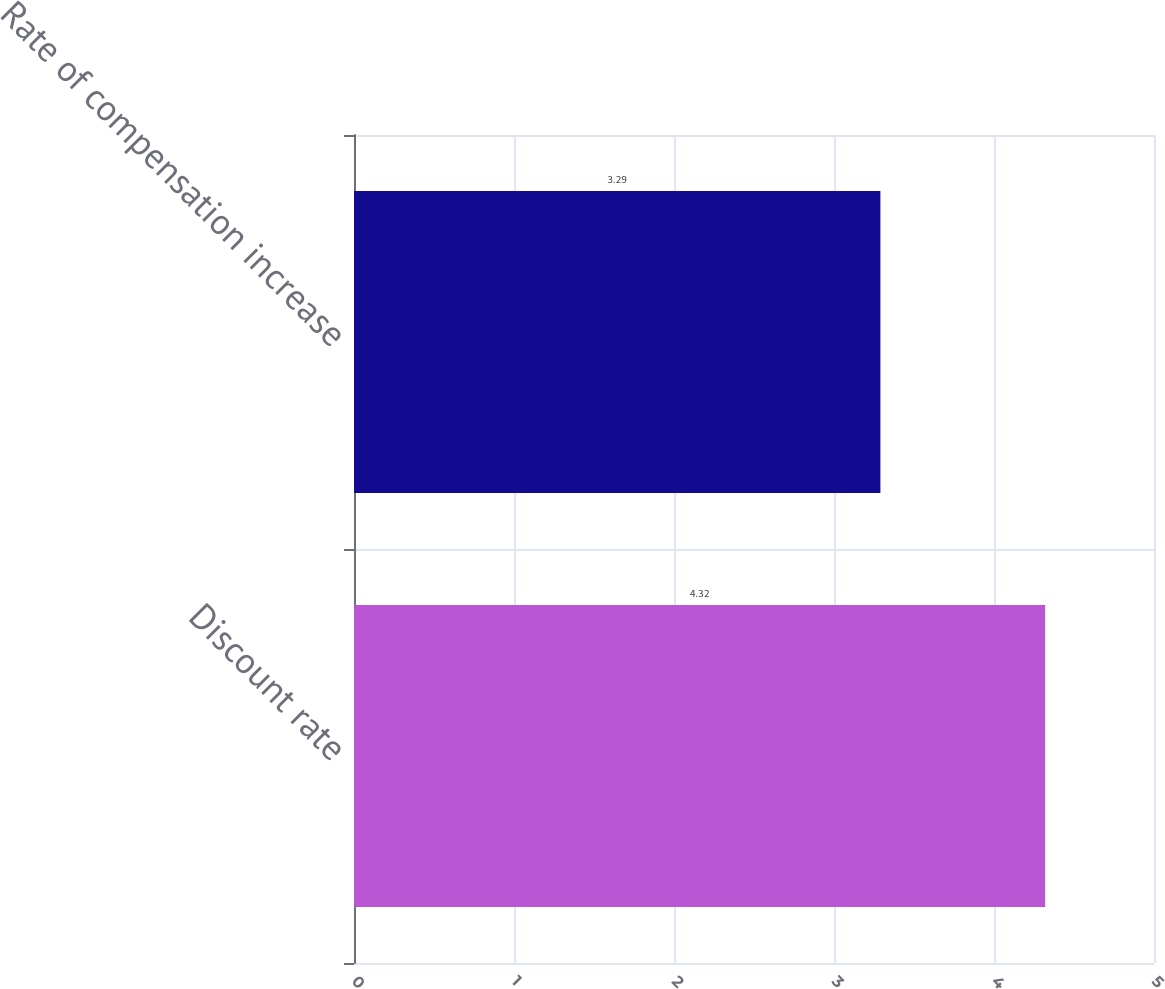Convert chart. <chart><loc_0><loc_0><loc_500><loc_500><bar_chart><fcel>Discount rate<fcel>Rate of compensation increase<nl><fcel>4.32<fcel>3.29<nl></chart> 